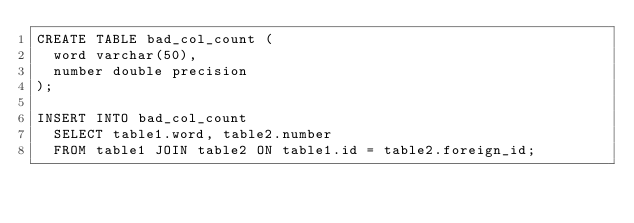<code> <loc_0><loc_0><loc_500><loc_500><_SQL_>CREATE TABLE bad_col_count (
  word varchar(50),
  number double precision
);

INSERT INTO bad_col_count
  SELECT table1.word, table2.number
  FROM table1 JOIN table2 ON table1.id = table2.foreign_id;
</code> 